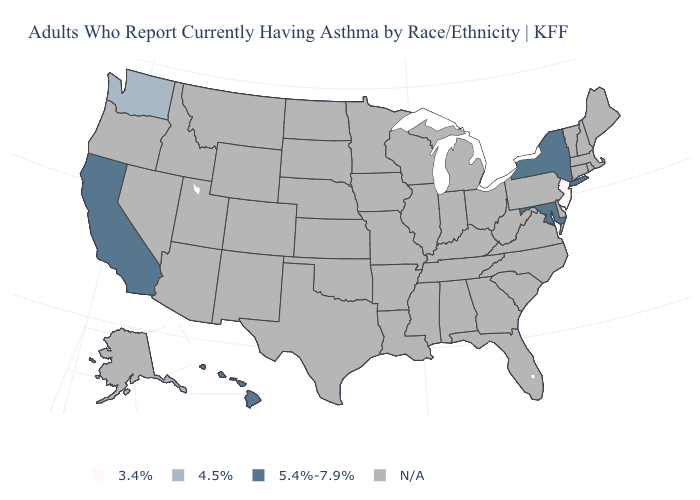Name the states that have a value in the range 4.5%?
Give a very brief answer. Washington. What is the value of Michigan?
Answer briefly. N/A. Name the states that have a value in the range 4.5%?
Short answer required. Washington. Name the states that have a value in the range 3.4%?
Concise answer only. New Jersey. Does the first symbol in the legend represent the smallest category?
Be succinct. Yes. Does New York have the highest value in the USA?
Answer briefly. Yes. Which states have the highest value in the USA?
Keep it brief. California, Hawaii, Maryland, New York. Which states hav the highest value in the South?
Give a very brief answer. Maryland. Which states have the lowest value in the USA?
Be succinct. New Jersey. What is the value of Rhode Island?
Answer briefly. N/A. What is the value of Hawaii?
Quick response, please. 5.4%-7.9%. 